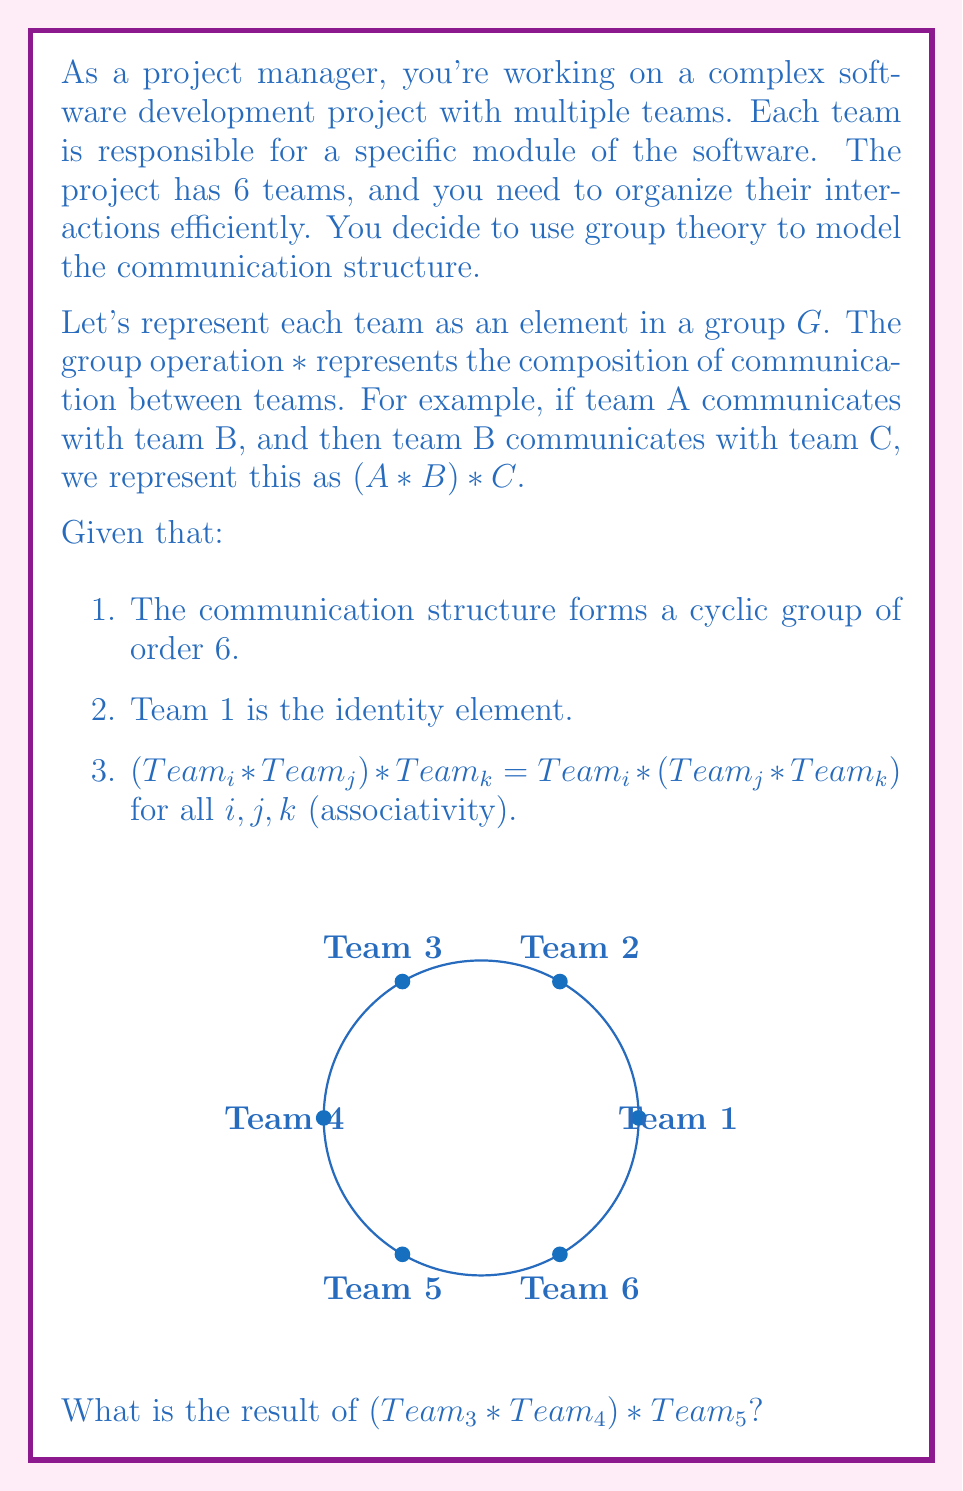What is the answer to this math problem? Let's approach this step-by-step:

1) First, we need to understand the properties of a cyclic group of order 6:
   - It has 6 elements
   - It can be generated by a single element
   - The elements follow a cyclic pattern

2) In this case, we can represent the teams as:
   $Team_1$ (identity), $Team_2$, $Team_3$, $Team_4$, $Team_5$, $Team_6$

3) Since $Team_1$ is the identity, we can infer that:
   $Team_2 * Team_2 = Team_3$
   $Team_2 * Team_3 = Team_4$
   $Team_2 * Team_4 = Team_5$
   $Team_2 * Team_5 = Team_6$
   $Team_2 * Team_6 = Team_1$

4) This means $Team_2$ is the generator of the group.

5) Now, let's solve $(Team_3 * Team_4) * Team_5$:
   - First, $Team_3 * Team_4$:
     $Team_3 * Team_4 = (Team_2 * Team_2) * (Team_2 * Team_3) = Team_2 * Team_5 = Team_6$

   - Then, $Team_6 * Team_5$:
     $Team_6 * Team_5 = (Team_2 * Team_5) * Team_5 = Team_2 * Team_4 = Team_5$

6) Therefore, $(Team_3 * Team_4) * Team_5 = Team_5$

This result demonstrates how group theory can model complex interactions in project management, allowing for efficient prediction of communication paths and team interactions.
Answer: $Team_5$ 